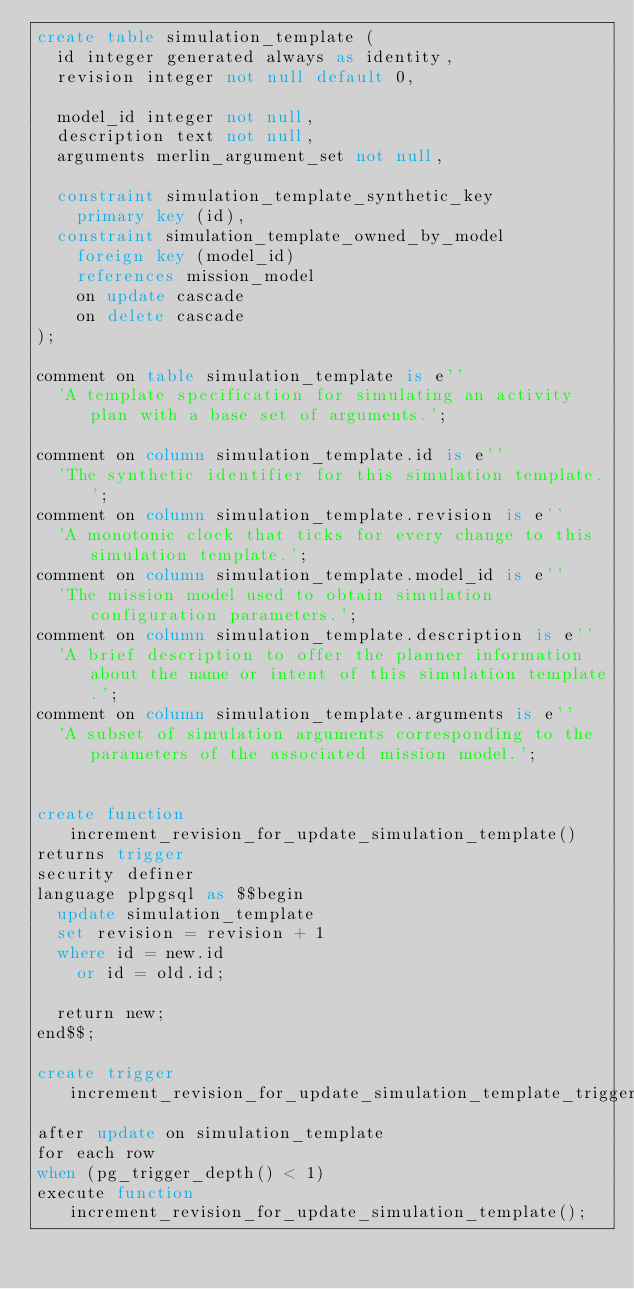<code> <loc_0><loc_0><loc_500><loc_500><_SQL_>create table simulation_template (
  id integer generated always as identity,
  revision integer not null default 0,

  model_id integer not null,
  description text not null,
  arguments merlin_argument_set not null,

  constraint simulation_template_synthetic_key
    primary key (id),
  constraint simulation_template_owned_by_model
    foreign key (model_id)
    references mission_model
    on update cascade
    on delete cascade
);

comment on table simulation_template is e''
  'A template specification for simulating an activity plan with a base set of arguments.';

comment on column simulation_template.id is e''
  'The synthetic identifier for this simulation template.';
comment on column simulation_template.revision is e''
  'A monotonic clock that ticks for every change to this simulation template.';
comment on column simulation_template.model_id is e''
  'The mission model used to obtain simulation configuration parameters.';
comment on column simulation_template.description is e''
  'A brief description to offer the planner information about the name or intent of this simulation template.';
comment on column simulation_template.arguments is e''
  'A subset of simulation arguments corresponding to the parameters of the associated mission model.';


create function increment_revision_for_update_simulation_template()
returns trigger
security definer
language plpgsql as $$begin
  update simulation_template
  set revision = revision + 1
  where id = new.id
    or id = old.id;

  return new;
end$$;

create trigger increment_revision_for_update_simulation_template_trigger
after update on simulation_template
for each row
when (pg_trigger_depth() < 1)
execute function increment_revision_for_update_simulation_template();
</code> 